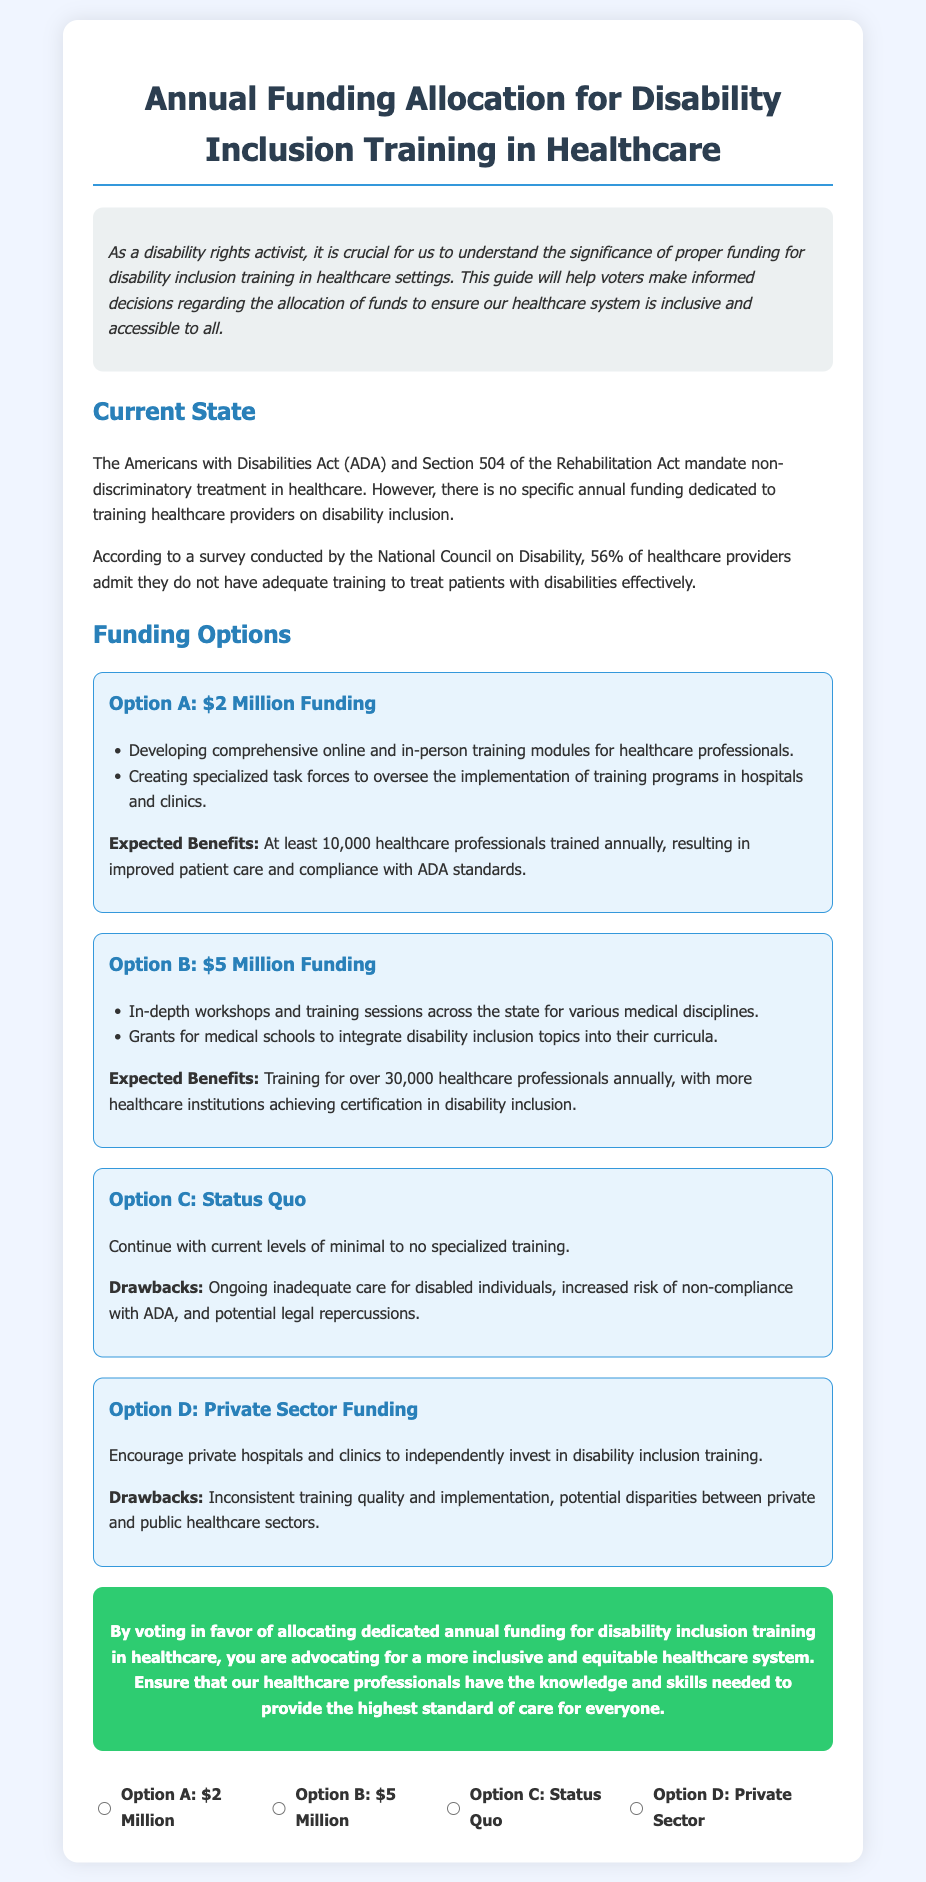What is the title of the document? The title of the document is presented at the top of the ballot, stating what the document is about.
Answer: Annual Funding Allocation for Disability Inclusion Training in Healthcare How much funding is proposed in Option A? Option A specifies an amount for funding that is explicitly mentioned in the description of the option.
Answer: $2 Million What percentage of healthcare providers lack adequate training for disabilities? The document provides statistical information from a survey regarding the level of training healthcare providers receive for treating patients with disabilities.
Answer: 56% What is the primary drawback of the Status Quo option? The drawbacks of the Status Quo option are highlighted in the document to show the potential negative impact of not changing the current training system.
Answer: Ongoing inadequate care How many healthcare professionals are expected to be trained annually under Option B? The expected benefits for Option B include a specific number of healthcare professionals who would receive training annually.
Answer: Over 30,000 What is a major issue with Private Sector Funding according to the document? The drawbacks of Private Sector Funding are discussed in the document, indicating a critical problem with such an approach.
Answer: Inconsistent training quality What call to action is presented at the end of the document? The final section of the document contains a persuasive statement encouraging voters to take a specific action regarding the funding allocation.
Answer: Vote in favor of allocating dedicated annual funding What is the expected outcome of Option A funding? The expected benefits of Option A include clear results from the funding allocation mentioned in its description.
Answer: Improved patient care 